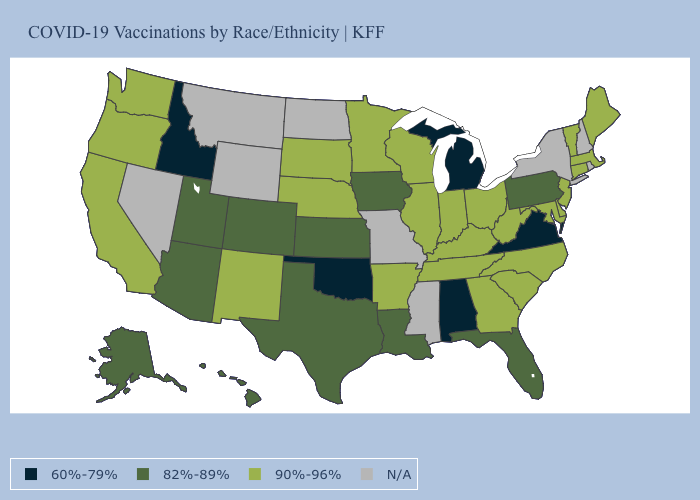What is the value of Louisiana?
Short answer required. 82%-89%. Which states have the highest value in the USA?
Concise answer only. Arkansas, California, Connecticut, Delaware, Georgia, Illinois, Indiana, Kentucky, Maine, Maryland, Massachusetts, Minnesota, Nebraska, New Jersey, New Mexico, North Carolina, Ohio, Oregon, South Carolina, South Dakota, Tennessee, Vermont, Washington, West Virginia, Wisconsin. Does the first symbol in the legend represent the smallest category?
Give a very brief answer. Yes. Which states have the lowest value in the West?
Give a very brief answer. Idaho. Name the states that have a value in the range 82%-89%?
Write a very short answer. Alaska, Arizona, Colorado, Florida, Hawaii, Iowa, Kansas, Louisiana, Pennsylvania, Texas, Utah. Does Michigan have the lowest value in the USA?
Give a very brief answer. Yes. Name the states that have a value in the range 90%-96%?
Short answer required. Arkansas, California, Connecticut, Delaware, Georgia, Illinois, Indiana, Kentucky, Maine, Maryland, Massachusetts, Minnesota, Nebraska, New Jersey, New Mexico, North Carolina, Ohio, Oregon, South Carolina, South Dakota, Tennessee, Vermont, Washington, West Virginia, Wisconsin. Which states have the lowest value in the MidWest?
Short answer required. Michigan. What is the value of Oregon?
Short answer required. 90%-96%. Among the states that border Michigan , which have the lowest value?
Give a very brief answer. Indiana, Ohio, Wisconsin. What is the lowest value in states that border Kentucky?
Keep it brief. 60%-79%. Does Michigan have the lowest value in the MidWest?
Keep it brief. Yes. Does Michigan have the lowest value in the USA?
Give a very brief answer. Yes. 